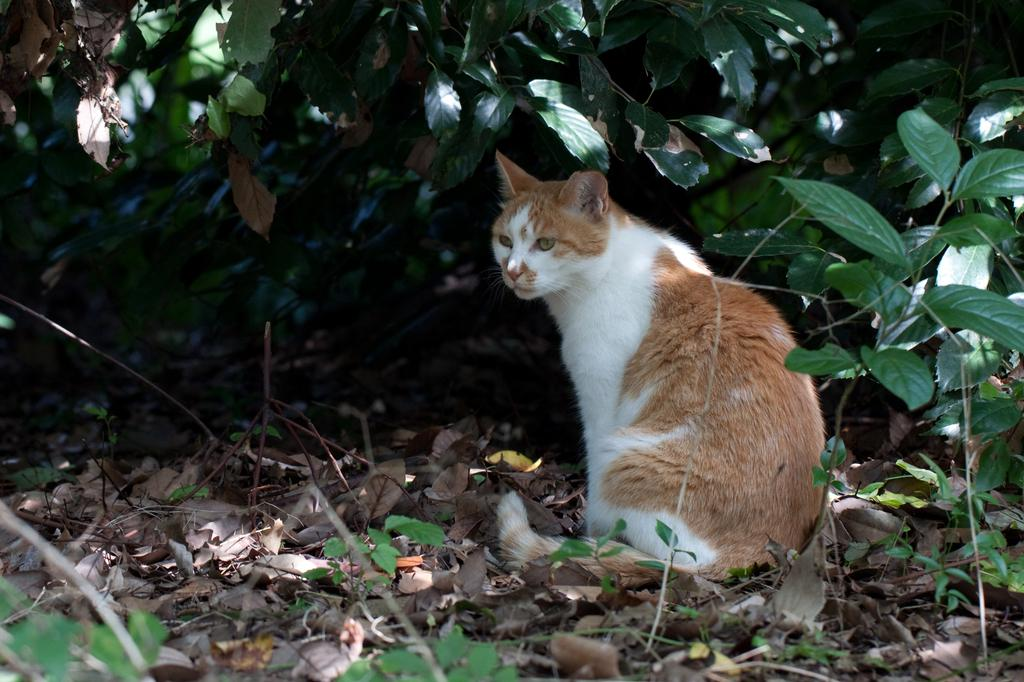What is the main subject in the center of the image? There is a cat in the center of the image. Can you describe the appearance of the cat? The cat is brown and white in color. What can be seen in the background of the image? There are plants and dry leaves in the background of the image. Are there any other objects visible in the background? Yes, there are a few other objects in the background of the image. What grade did the cat receive on its recent exam in the image? There is no indication of an exam or grade in the image; it features a cat and its surroundings. 